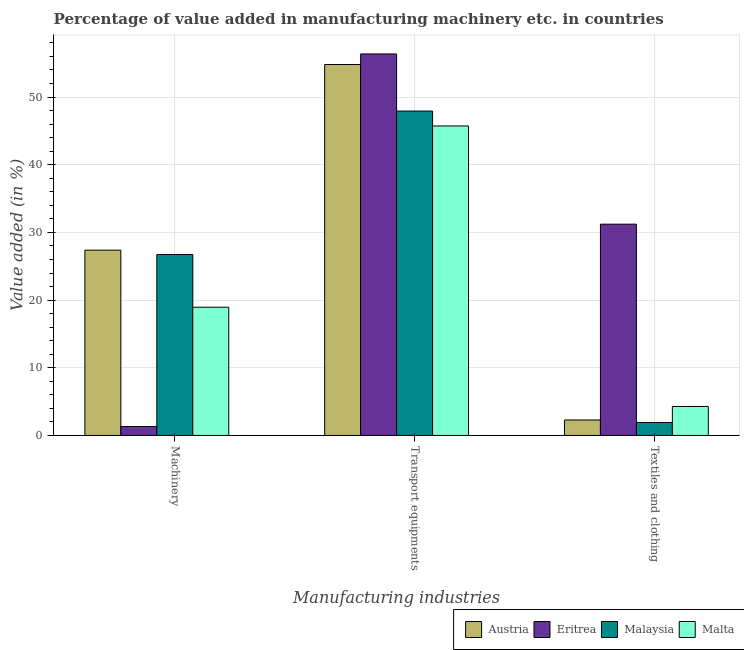How many different coloured bars are there?
Your answer should be compact. 4. How many groups of bars are there?
Your answer should be compact. 3. Are the number of bars per tick equal to the number of legend labels?
Your answer should be very brief. Yes. How many bars are there on the 1st tick from the left?
Your answer should be compact. 4. What is the label of the 1st group of bars from the left?
Your answer should be very brief. Machinery. What is the value added in manufacturing transport equipments in Malta?
Give a very brief answer. 45.73. Across all countries, what is the maximum value added in manufacturing machinery?
Your response must be concise. 27.38. Across all countries, what is the minimum value added in manufacturing machinery?
Your response must be concise. 1.32. In which country was the value added in manufacturing textile and clothing maximum?
Ensure brevity in your answer.  Eritrea. In which country was the value added in manufacturing transport equipments minimum?
Offer a very short reply. Malta. What is the total value added in manufacturing machinery in the graph?
Ensure brevity in your answer.  74.37. What is the difference between the value added in manufacturing textile and clothing in Malaysia and that in Austria?
Give a very brief answer. -0.38. What is the difference between the value added in manufacturing machinery in Malta and the value added in manufacturing textile and clothing in Eritrea?
Make the answer very short. -12.27. What is the average value added in manufacturing textile and clothing per country?
Give a very brief answer. 9.92. What is the difference between the value added in manufacturing textile and clothing and value added in manufacturing machinery in Eritrea?
Offer a terse response. 29.9. In how many countries, is the value added in manufacturing textile and clothing greater than 38 %?
Keep it short and to the point. 0. What is the ratio of the value added in manufacturing transport equipments in Malaysia to that in Malta?
Make the answer very short. 1.05. What is the difference between the highest and the second highest value added in manufacturing textile and clothing?
Give a very brief answer. 26.94. What is the difference between the highest and the lowest value added in manufacturing transport equipments?
Provide a short and direct response. 10.64. Is the sum of the value added in manufacturing transport equipments in Malaysia and Malta greater than the maximum value added in manufacturing textile and clothing across all countries?
Ensure brevity in your answer.  Yes. What does the 4th bar from the left in Textiles and clothing represents?
Keep it short and to the point. Malta. What does the 4th bar from the right in Transport equipments represents?
Ensure brevity in your answer.  Austria. How many bars are there?
Keep it short and to the point. 12. Does the graph contain any zero values?
Make the answer very short. No. Where does the legend appear in the graph?
Keep it short and to the point. Bottom right. How many legend labels are there?
Ensure brevity in your answer.  4. What is the title of the graph?
Your answer should be very brief. Percentage of value added in manufacturing machinery etc. in countries. What is the label or title of the X-axis?
Your response must be concise. Manufacturing industries. What is the label or title of the Y-axis?
Provide a succinct answer. Value added (in %). What is the Value added (in %) of Austria in Machinery?
Ensure brevity in your answer.  27.38. What is the Value added (in %) of Eritrea in Machinery?
Offer a terse response. 1.32. What is the Value added (in %) of Malaysia in Machinery?
Your answer should be compact. 26.73. What is the Value added (in %) of Malta in Machinery?
Your response must be concise. 18.94. What is the Value added (in %) of Austria in Transport equipments?
Provide a short and direct response. 54.81. What is the Value added (in %) in Eritrea in Transport equipments?
Offer a very short reply. 56.37. What is the Value added (in %) of Malaysia in Transport equipments?
Your answer should be compact. 47.93. What is the Value added (in %) in Malta in Transport equipments?
Provide a short and direct response. 45.73. What is the Value added (in %) in Austria in Textiles and clothing?
Your answer should be very brief. 2.29. What is the Value added (in %) of Eritrea in Textiles and clothing?
Give a very brief answer. 31.22. What is the Value added (in %) of Malaysia in Textiles and clothing?
Offer a terse response. 1.91. What is the Value added (in %) of Malta in Textiles and clothing?
Provide a short and direct response. 4.28. Across all Manufacturing industries, what is the maximum Value added (in %) in Austria?
Your answer should be compact. 54.81. Across all Manufacturing industries, what is the maximum Value added (in %) of Eritrea?
Keep it short and to the point. 56.37. Across all Manufacturing industries, what is the maximum Value added (in %) of Malaysia?
Give a very brief answer. 47.93. Across all Manufacturing industries, what is the maximum Value added (in %) of Malta?
Provide a short and direct response. 45.73. Across all Manufacturing industries, what is the minimum Value added (in %) of Austria?
Provide a succinct answer. 2.29. Across all Manufacturing industries, what is the minimum Value added (in %) of Eritrea?
Ensure brevity in your answer.  1.32. Across all Manufacturing industries, what is the minimum Value added (in %) of Malaysia?
Give a very brief answer. 1.91. Across all Manufacturing industries, what is the minimum Value added (in %) of Malta?
Offer a very short reply. 4.28. What is the total Value added (in %) of Austria in the graph?
Your answer should be very brief. 84.47. What is the total Value added (in %) in Eritrea in the graph?
Ensure brevity in your answer.  88.91. What is the total Value added (in %) of Malaysia in the graph?
Offer a very short reply. 76.56. What is the total Value added (in %) in Malta in the graph?
Offer a terse response. 68.95. What is the difference between the Value added (in %) of Austria in Machinery and that in Transport equipments?
Provide a succinct answer. -27.43. What is the difference between the Value added (in %) in Eritrea in Machinery and that in Transport equipments?
Your answer should be compact. -55.05. What is the difference between the Value added (in %) of Malaysia in Machinery and that in Transport equipments?
Provide a succinct answer. -21.2. What is the difference between the Value added (in %) in Malta in Machinery and that in Transport equipments?
Provide a succinct answer. -26.79. What is the difference between the Value added (in %) in Austria in Machinery and that in Textiles and clothing?
Keep it short and to the point. 25.09. What is the difference between the Value added (in %) of Eritrea in Machinery and that in Textiles and clothing?
Your response must be concise. -29.9. What is the difference between the Value added (in %) of Malaysia in Machinery and that in Textiles and clothing?
Offer a terse response. 24.82. What is the difference between the Value added (in %) of Malta in Machinery and that in Textiles and clothing?
Your answer should be very brief. 14.66. What is the difference between the Value added (in %) in Austria in Transport equipments and that in Textiles and clothing?
Make the answer very short. 52.52. What is the difference between the Value added (in %) in Eritrea in Transport equipments and that in Textiles and clothing?
Give a very brief answer. 25.15. What is the difference between the Value added (in %) in Malaysia in Transport equipments and that in Textiles and clothing?
Provide a short and direct response. 46.02. What is the difference between the Value added (in %) in Malta in Transport equipments and that in Textiles and clothing?
Offer a very short reply. 41.45. What is the difference between the Value added (in %) of Austria in Machinery and the Value added (in %) of Eritrea in Transport equipments?
Offer a very short reply. -28.99. What is the difference between the Value added (in %) in Austria in Machinery and the Value added (in %) in Malaysia in Transport equipments?
Your response must be concise. -20.55. What is the difference between the Value added (in %) of Austria in Machinery and the Value added (in %) of Malta in Transport equipments?
Offer a very short reply. -18.35. What is the difference between the Value added (in %) of Eritrea in Machinery and the Value added (in %) of Malaysia in Transport equipments?
Offer a terse response. -46.61. What is the difference between the Value added (in %) in Eritrea in Machinery and the Value added (in %) in Malta in Transport equipments?
Make the answer very short. -44.41. What is the difference between the Value added (in %) in Malaysia in Machinery and the Value added (in %) in Malta in Transport equipments?
Provide a succinct answer. -19. What is the difference between the Value added (in %) in Austria in Machinery and the Value added (in %) in Eritrea in Textiles and clothing?
Provide a succinct answer. -3.84. What is the difference between the Value added (in %) of Austria in Machinery and the Value added (in %) of Malaysia in Textiles and clothing?
Provide a short and direct response. 25.47. What is the difference between the Value added (in %) in Austria in Machinery and the Value added (in %) in Malta in Textiles and clothing?
Offer a terse response. 23.1. What is the difference between the Value added (in %) in Eritrea in Machinery and the Value added (in %) in Malaysia in Textiles and clothing?
Ensure brevity in your answer.  -0.59. What is the difference between the Value added (in %) in Eritrea in Machinery and the Value added (in %) in Malta in Textiles and clothing?
Your answer should be very brief. -2.96. What is the difference between the Value added (in %) of Malaysia in Machinery and the Value added (in %) of Malta in Textiles and clothing?
Your response must be concise. 22.45. What is the difference between the Value added (in %) of Austria in Transport equipments and the Value added (in %) of Eritrea in Textiles and clothing?
Make the answer very short. 23.59. What is the difference between the Value added (in %) in Austria in Transport equipments and the Value added (in %) in Malaysia in Textiles and clothing?
Offer a terse response. 52.9. What is the difference between the Value added (in %) of Austria in Transport equipments and the Value added (in %) of Malta in Textiles and clothing?
Your response must be concise. 50.53. What is the difference between the Value added (in %) in Eritrea in Transport equipments and the Value added (in %) in Malaysia in Textiles and clothing?
Provide a short and direct response. 54.46. What is the difference between the Value added (in %) of Eritrea in Transport equipments and the Value added (in %) of Malta in Textiles and clothing?
Your answer should be compact. 52.09. What is the difference between the Value added (in %) in Malaysia in Transport equipments and the Value added (in %) in Malta in Textiles and clothing?
Give a very brief answer. 43.65. What is the average Value added (in %) in Austria per Manufacturing industries?
Ensure brevity in your answer.  28.16. What is the average Value added (in %) of Eritrea per Manufacturing industries?
Your answer should be compact. 29.64. What is the average Value added (in %) in Malaysia per Manufacturing industries?
Provide a succinct answer. 25.52. What is the average Value added (in %) in Malta per Manufacturing industries?
Provide a short and direct response. 22.98. What is the difference between the Value added (in %) of Austria and Value added (in %) of Eritrea in Machinery?
Ensure brevity in your answer.  26.06. What is the difference between the Value added (in %) in Austria and Value added (in %) in Malaysia in Machinery?
Offer a very short reply. 0.65. What is the difference between the Value added (in %) of Austria and Value added (in %) of Malta in Machinery?
Keep it short and to the point. 8.43. What is the difference between the Value added (in %) in Eritrea and Value added (in %) in Malaysia in Machinery?
Keep it short and to the point. -25.41. What is the difference between the Value added (in %) of Eritrea and Value added (in %) of Malta in Machinery?
Provide a succinct answer. -17.62. What is the difference between the Value added (in %) of Malaysia and Value added (in %) of Malta in Machinery?
Keep it short and to the point. 7.79. What is the difference between the Value added (in %) in Austria and Value added (in %) in Eritrea in Transport equipments?
Offer a very short reply. -1.56. What is the difference between the Value added (in %) in Austria and Value added (in %) in Malaysia in Transport equipments?
Your answer should be very brief. 6.88. What is the difference between the Value added (in %) in Austria and Value added (in %) in Malta in Transport equipments?
Give a very brief answer. 9.08. What is the difference between the Value added (in %) in Eritrea and Value added (in %) in Malaysia in Transport equipments?
Offer a terse response. 8.44. What is the difference between the Value added (in %) in Eritrea and Value added (in %) in Malta in Transport equipments?
Give a very brief answer. 10.64. What is the difference between the Value added (in %) of Malaysia and Value added (in %) of Malta in Transport equipments?
Give a very brief answer. 2.2. What is the difference between the Value added (in %) in Austria and Value added (in %) in Eritrea in Textiles and clothing?
Your answer should be very brief. -28.93. What is the difference between the Value added (in %) of Austria and Value added (in %) of Malaysia in Textiles and clothing?
Give a very brief answer. 0.38. What is the difference between the Value added (in %) in Austria and Value added (in %) in Malta in Textiles and clothing?
Provide a succinct answer. -1.99. What is the difference between the Value added (in %) in Eritrea and Value added (in %) in Malaysia in Textiles and clothing?
Provide a succinct answer. 29.31. What is the difference between the Value added (in %) in Eritrea and Value added (in %) in Malta in Textiles and clothing?
Your response must be concise. 26.94. What is the difference between the Value added (in %) of Malaysia and Value added (in %) of Malta in Textiles and clothing?
Offer a very short reply. -2.37. What is the ratio of the Value added (in %) in Austria in Machinery to that in Transport equipments?
Your response must be concise. 0.5. What is the ratio of the Value added (in %) in Eritrea in Machinery to that in Transport equipments?
Your answer should be very brief. 0.02. What is the ratio of the Value added (in %) in Malaysia in Machinery to that in Transport equipments?
Your answer should be very brief. 0.56. What is the ratio of the Value added (in %) in Malta in Machinery to that in Transport equipments?
Your response must be concise. 0.41. What is the ratio of the Value added (in %) of Austria in Machinery to that in Textiles and clothing?
Provide a succinct answer. 11.98. What is the ratio of the Value added (in %) in Eritrea in Machinery to that in Textiles and clothing?
Your response must be concise. 0.04. What is the ratio of the Value added (in %) of Malaysia in Machinery to that in Textiles and clothing?
Your response must be concise. 14.03. What is the ratio of the Value added (in %) in Malta in Machinery to that in Textiles and clothing?
Your answer should be compact. 4.43. What is the ratio of the Value added (in %) of Austria in Transport equipments to that in Textiles and clothing?
Your answer should be very brief. 23.98. What is the ratio of the Value added (in %) in Eritrea in Transport equipments to that in Textiles and clothing?
Your response must be concise. 1.81. What is the ratio of the Value added (in %) of Malaysia in Transport equipments to that in Textiles and clothing?
Keep it short and to the point. 25.15. What is the ratio of the Value added (in %) of Malta in Transport equipments to that in Textiles and clothing?
Offer a terse response. 10.69. What is the difference between the highest and the second highest Value added (in %) in Austria?
Offer a very short reply. 27.43. What is the difference between the highest and the second highest Value added (in %) in Eritrea?
Give a very brief answer. 25.15. What is the difference between the highest and the second highest Value added (in %) in Malaysia?
Your response must be concise. 21.2. What is the difference between the highest and the second highest Value added (in %) of Malta?
Provide a succinct answer. 26.79. What is the difference between the highest and the lowest Value added (in %) in Austria?
Offer a terse response. 52.52. What is the difference between the highest and the lowest Value added (in %) in Eritrea?
Offer a terse response. 55.05. What is the difference between the highest and the lowest Value added (in %) of Malaysia?
Give a very brief answer. 46.02. What is the difference between the highest and the lowest Value added (in %) in Malta?
Provide a short and direct response. 41.45. 